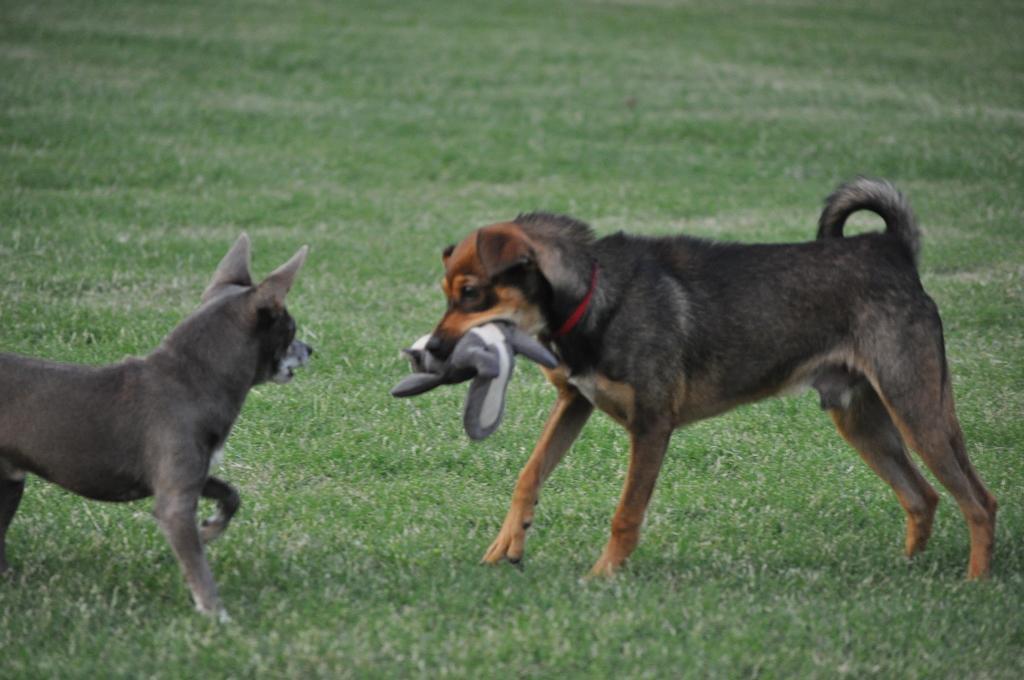How would you summarize this image in a sentence or two? In the foreground, I can see two dogs on grass and one dog is holding an object in mouth. This picture might be taken in a park. 